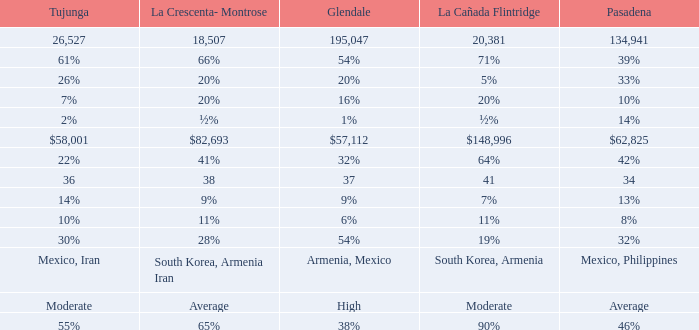What is the proportion of tukunga when la crescenta-montrose constitutes 28%? 30%. 